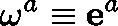Convert formula to latex. <formula><loc_0><loc_0><loc_500><loc_500>\omega ^ { a } \equiv e ^ { a }</formula> 